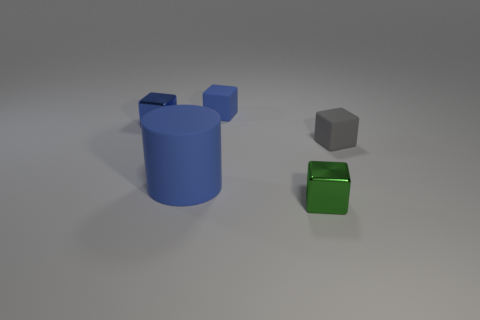How are the objects positioned relative to each other? The objects are placed with a sense of depth. The large blue cylinder is at the forefront, the small green cube is slightly to the middle, and the tiny gray cube is the furthest away in the composition. 